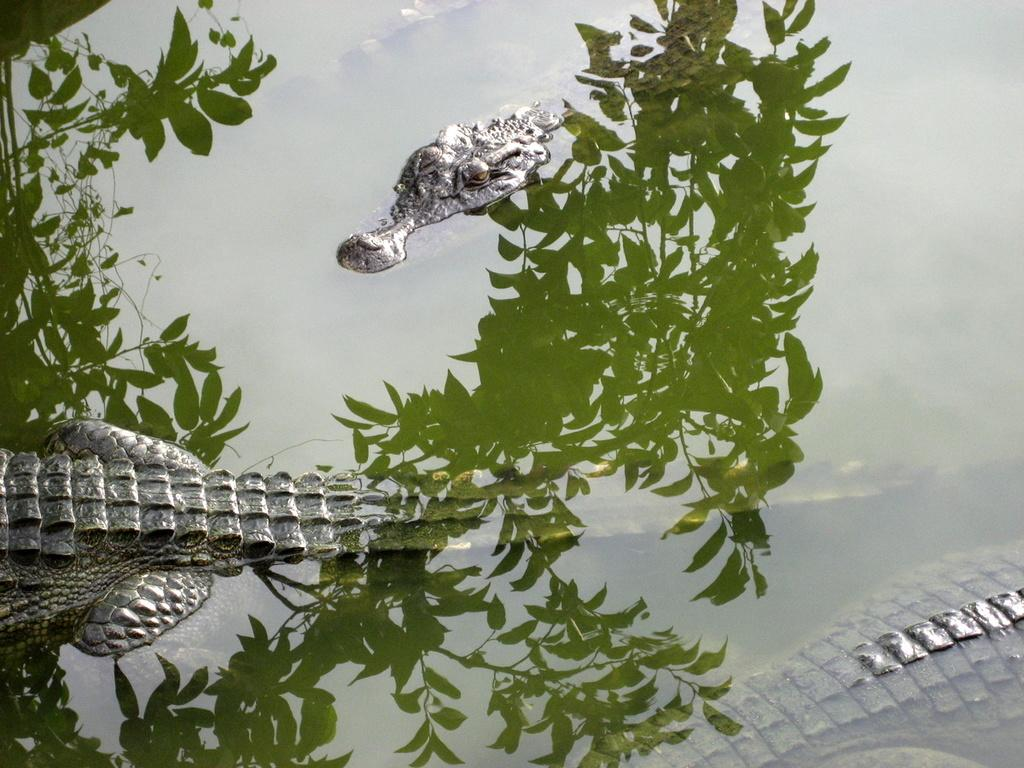What type of animals are in the water in the image? There are crocodiles in the water in the image. What else can be seen in the image besides the crocodiles? The shadow of a tree is visible in the image. What type of celery can be seen growing near the crocodiles in the image? There is no celery present in the image; it only features crocodiles in the water and the shadow of a tree. 